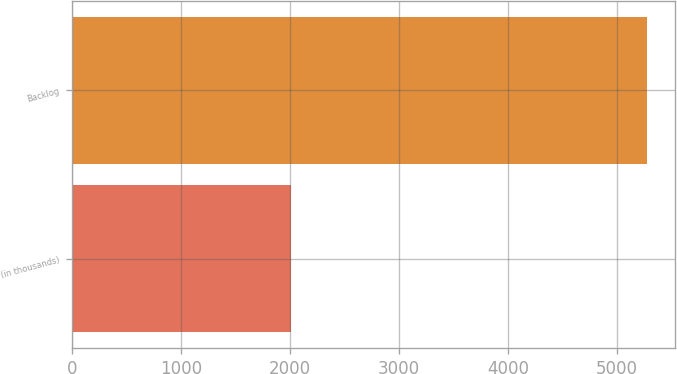Convert chart. <chart><loc_0><loc_0><loc_500><loc_500><bar_chart><fcel>(in thousands)<fcel>Backlog<nl><fcel>2008<fcel>5271<nl></chart> 